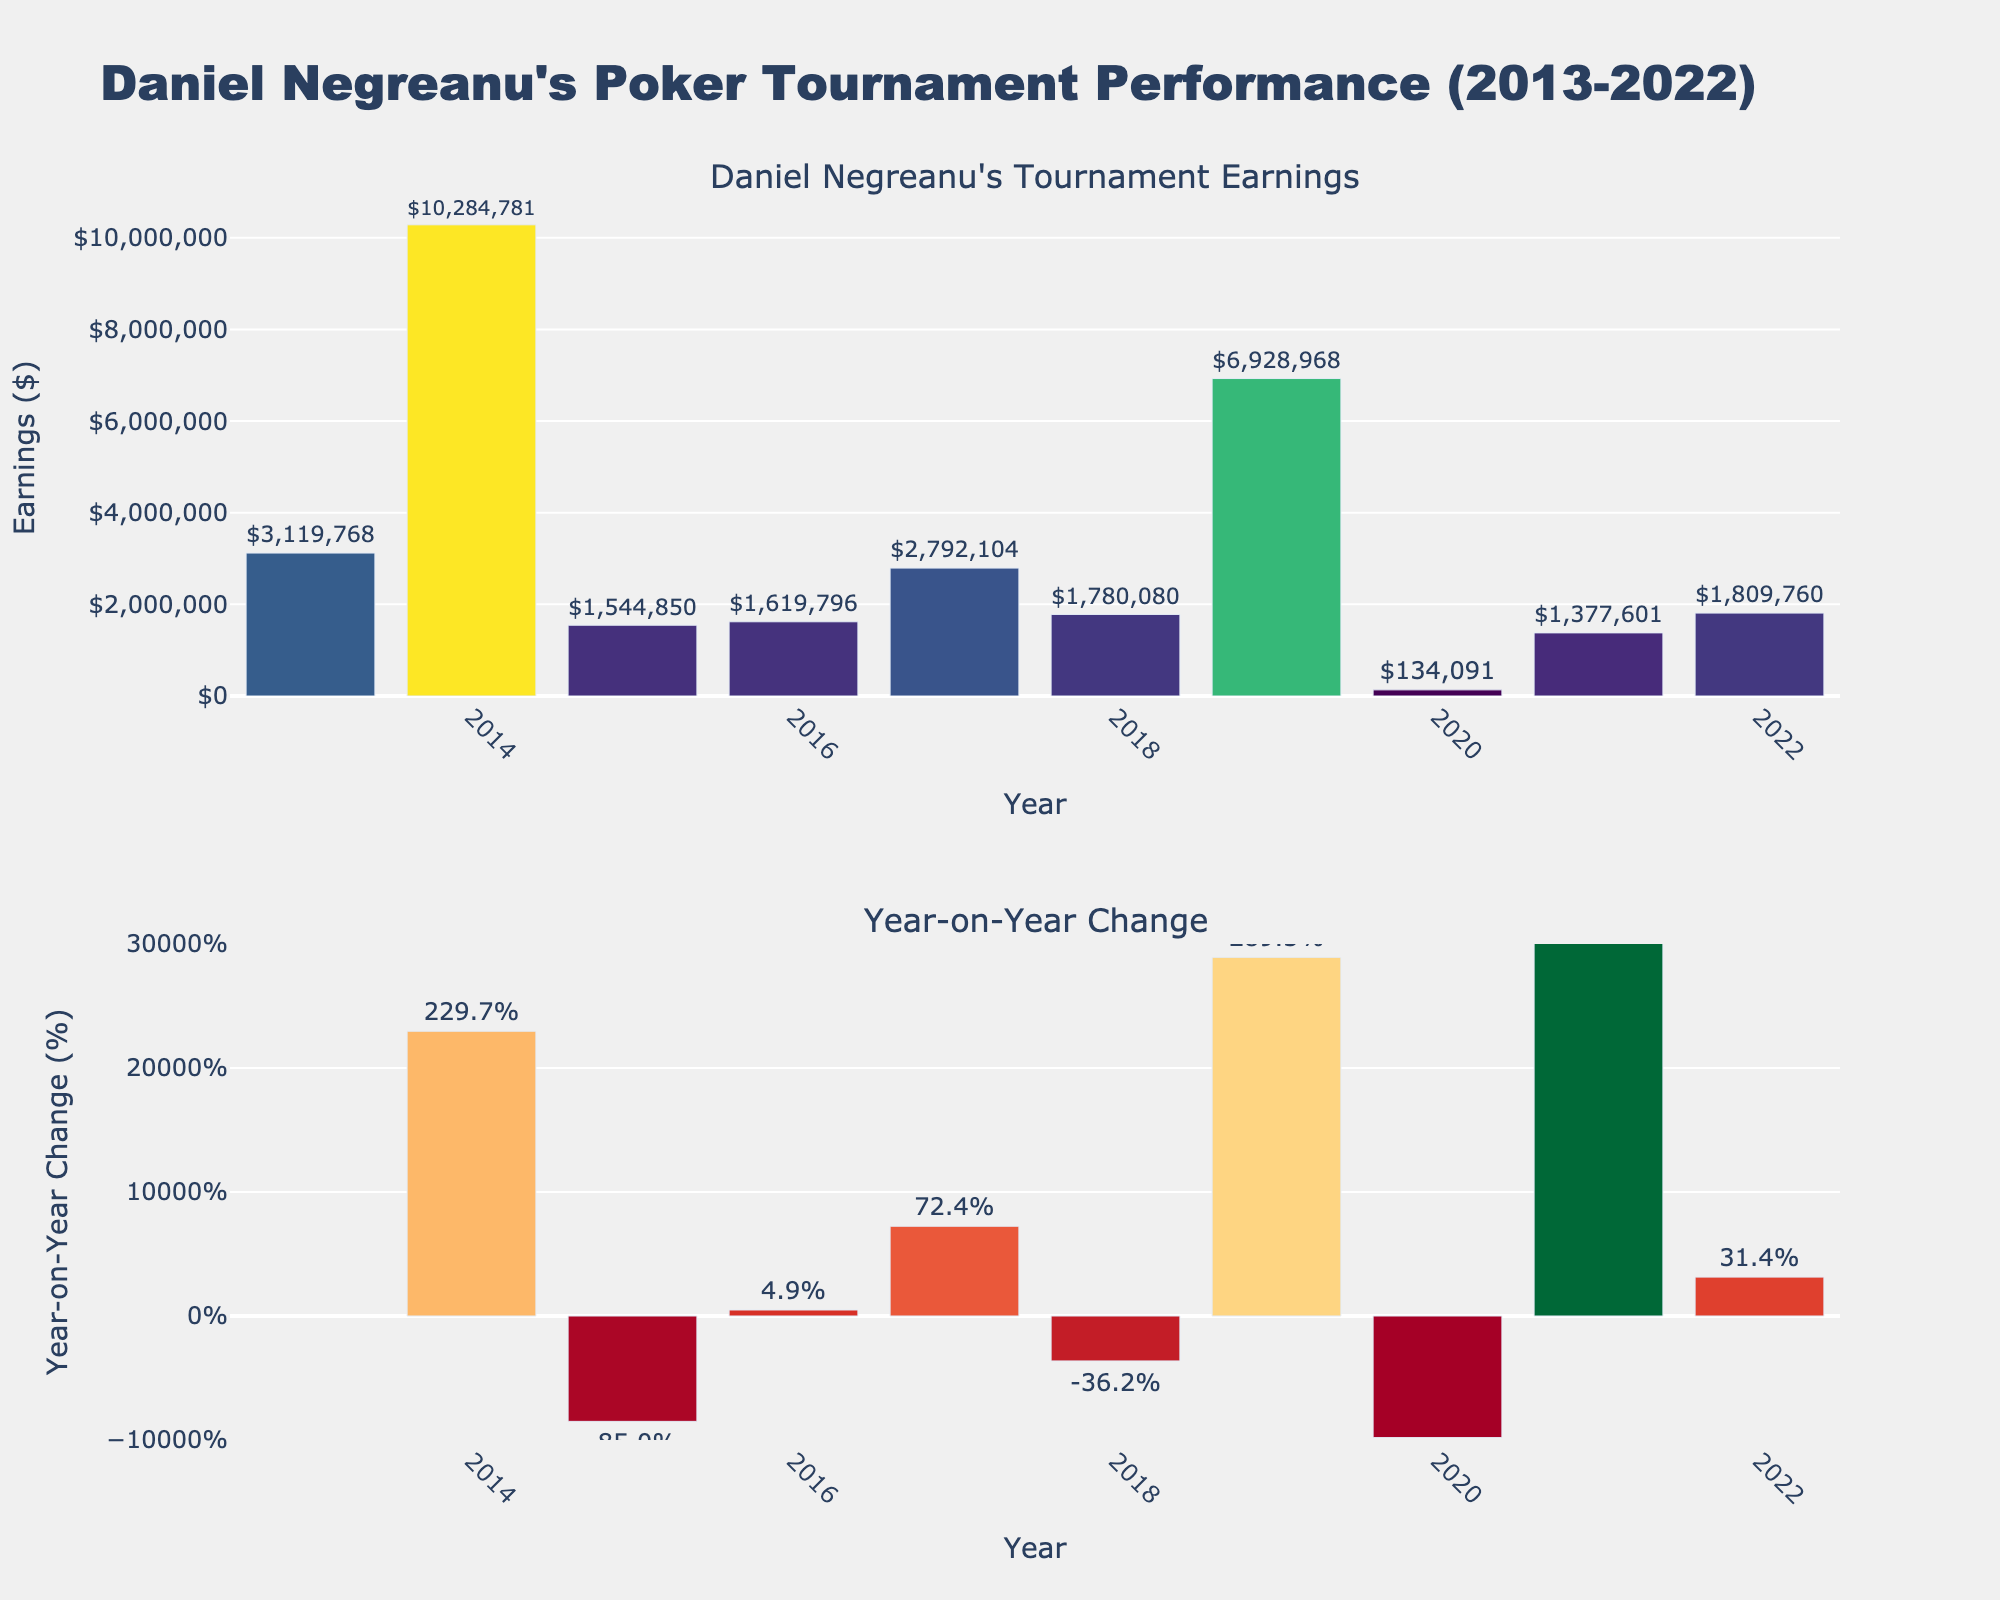How many subplots are there in the figure? The figure has four subplots, as indicated by the four subplot titles: Single Family, Townhouse, Condo, and Duplex.
Answer: Four What is the title of the figure? The title of the figure is "Average Home Values in Forest Lane Neighborhood (2013-2022)," as shown at the top of the plot.
Answer: Average Home Values in Forest Lane Neighborhood (2013-2022) Which property type had the highest average home value in 2022? The "Single Family" property type had the highest average home value in 2022, as seen by the tallest bar in the 2022 section of its subplot.
Answer: Single Family What is the trend in home values for condos from 2013 to 2022? The subplot for "Condo" shows an increasing trend in home values from 2013 to 2022, with each year's bar higher than the previous year's.
Answer: Increasing What were the average home values for townhouses in 2019 and 2020, and what is the difference between these two values? The average home value for townhouses in 2019 was $325,000, and in 2020, it was $350,000. The difference is $350,000 - $325,000 = $25,000.
Answer: $25,000 Which year had the smallest increase in home values for duplexes compared to the previous year? The smallest increase for duplexes occurred between 2013 ($245,000) and 2014 ($255,000), with a difference of $10,000.
Answer: 2014 How does the average home value for single-family homes in 2021 compare to that in 2013? In 2021, the average home value for single-family homes was $485,000, while in 2013, it was $280,000. The difference is $485,000 - $280,000 = $205,000.
Answer: $205,000 Which property type shows the most consistent rise in home values over the years? The "Single Family" home type shows the most consistent rise in home values, with each year's bar clearly higher than the previous year's without any decline.
Answer: Single Family What is the average home value for townhouses over the decade? To find the average home value for townhouses over the decade, sum the values from each year: $220,000 + $230,000 + $245,000 + $260,000 + $280,000 + $300,000 + $325,000 + $350,000 + $380,000 + $415,000 = $3,305,000. Then divide by the number of years: $3,305,000 / 10 = $330,500.
Answer: $330,500 Comparing condos and duplexes, which property type had a higher average home value in 2020? In 2020, the average home value for condos was $285,000 and for duplexes, it was $390,000. Therefore, duplexes had a higher average home value.
Answer: Duplexes 